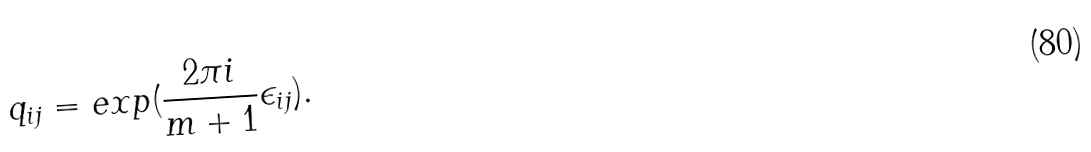Convert formula to latex. <formula><loc_0><loc_0><loc_500><loc_500>q _ { i j } = e x p ( \frac { 2 \pi i } { m + 1 } \epsilon _ { i j } ) .</formula> 